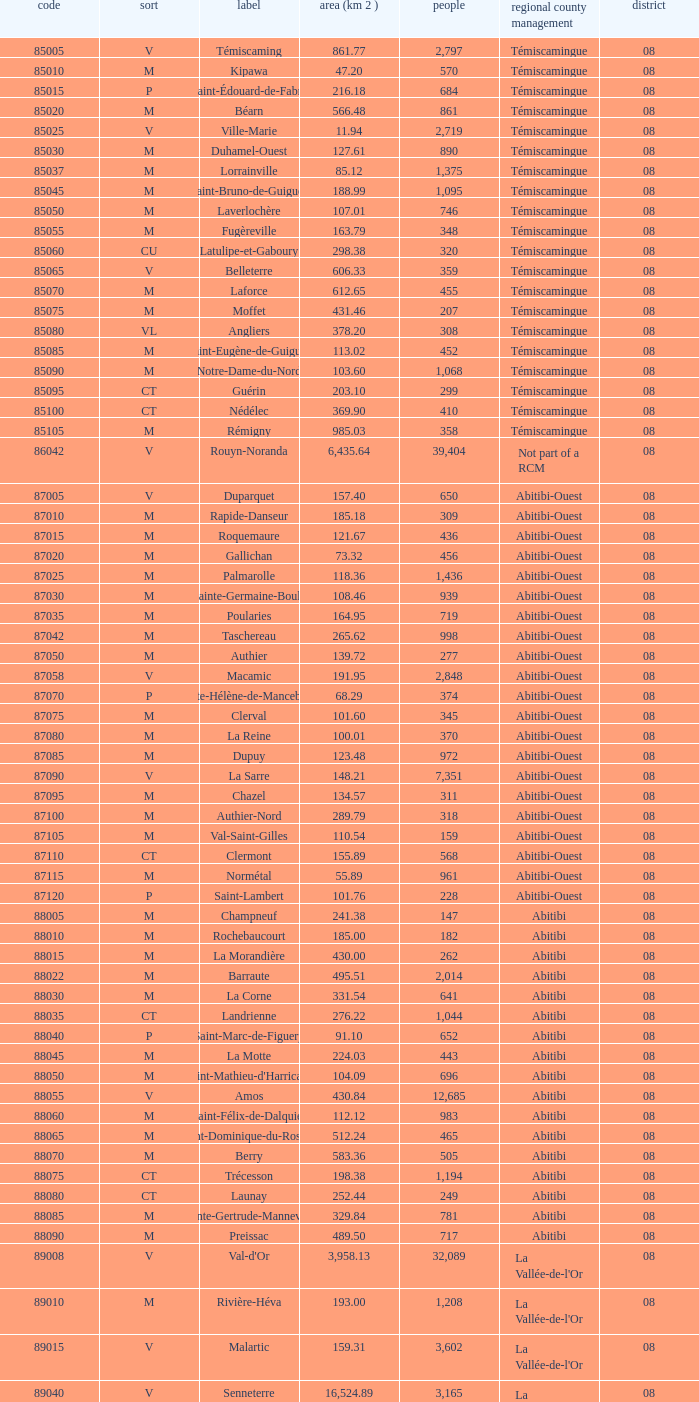What is the km2 area for the population of 311? 134.57. 